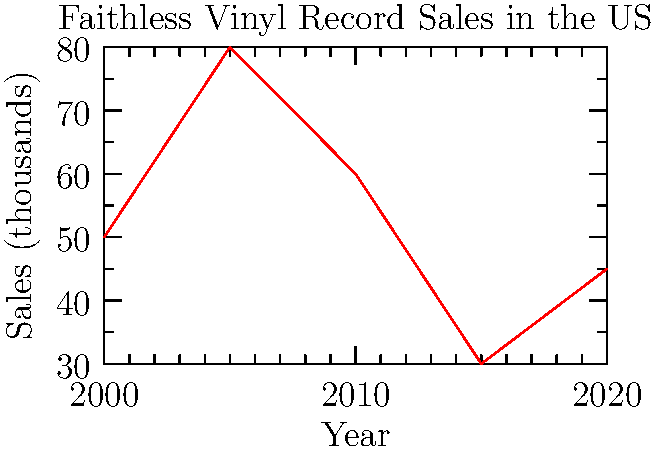Based on the graph showing Faithless vinyl record sales in the US over the past two decades, which year saw the highest sales, and what was the approximate sales figure in thousands? To answer this question, we need to analyze the graph of Faithless vinyl record sales in the US from 2000 to 2020:

1. The x-axis represents the years from 2000 to 2020 in 5-year intervals.
2. The y-axis represents sales in thousands of units.
3. We can see that the line graph peaks at a single point.
4. This peak occurs at the second data point on the x-axis, which corresponds to the year 2005.
5. The y-value at this peak is approximately 80 on the scale.

Therefore, the highest sales occurred in 2005, with approximately 80,000 vinyl records sold.
Answer: 2005, 80,000 